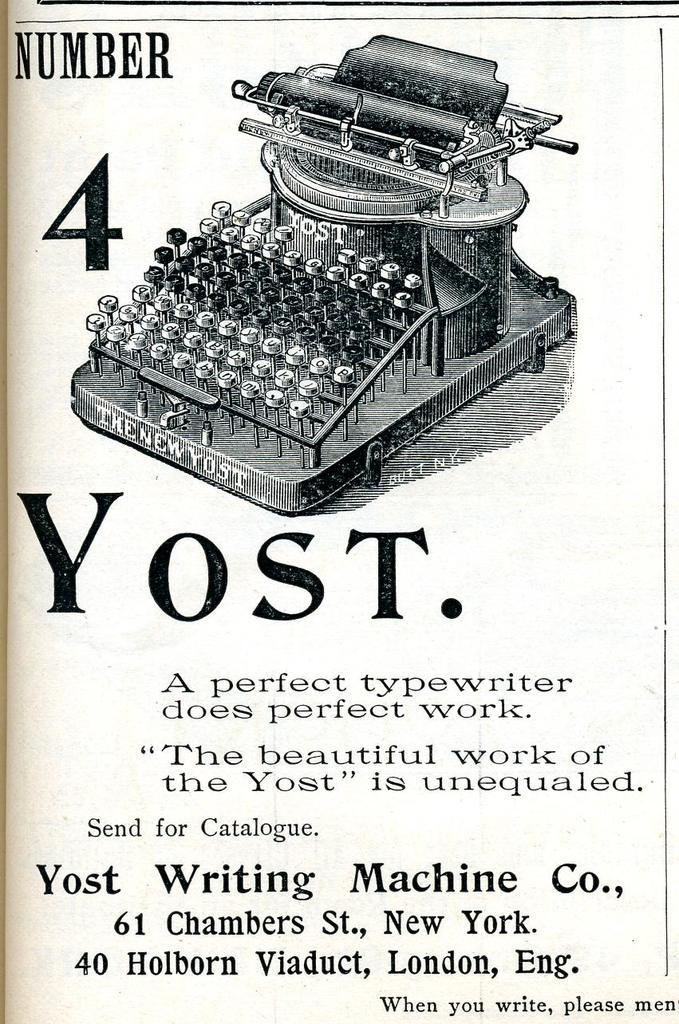<image>
Write a terse but informative summary of the picture. An ad for an old manual typewriter that says Number 4 Yost. 